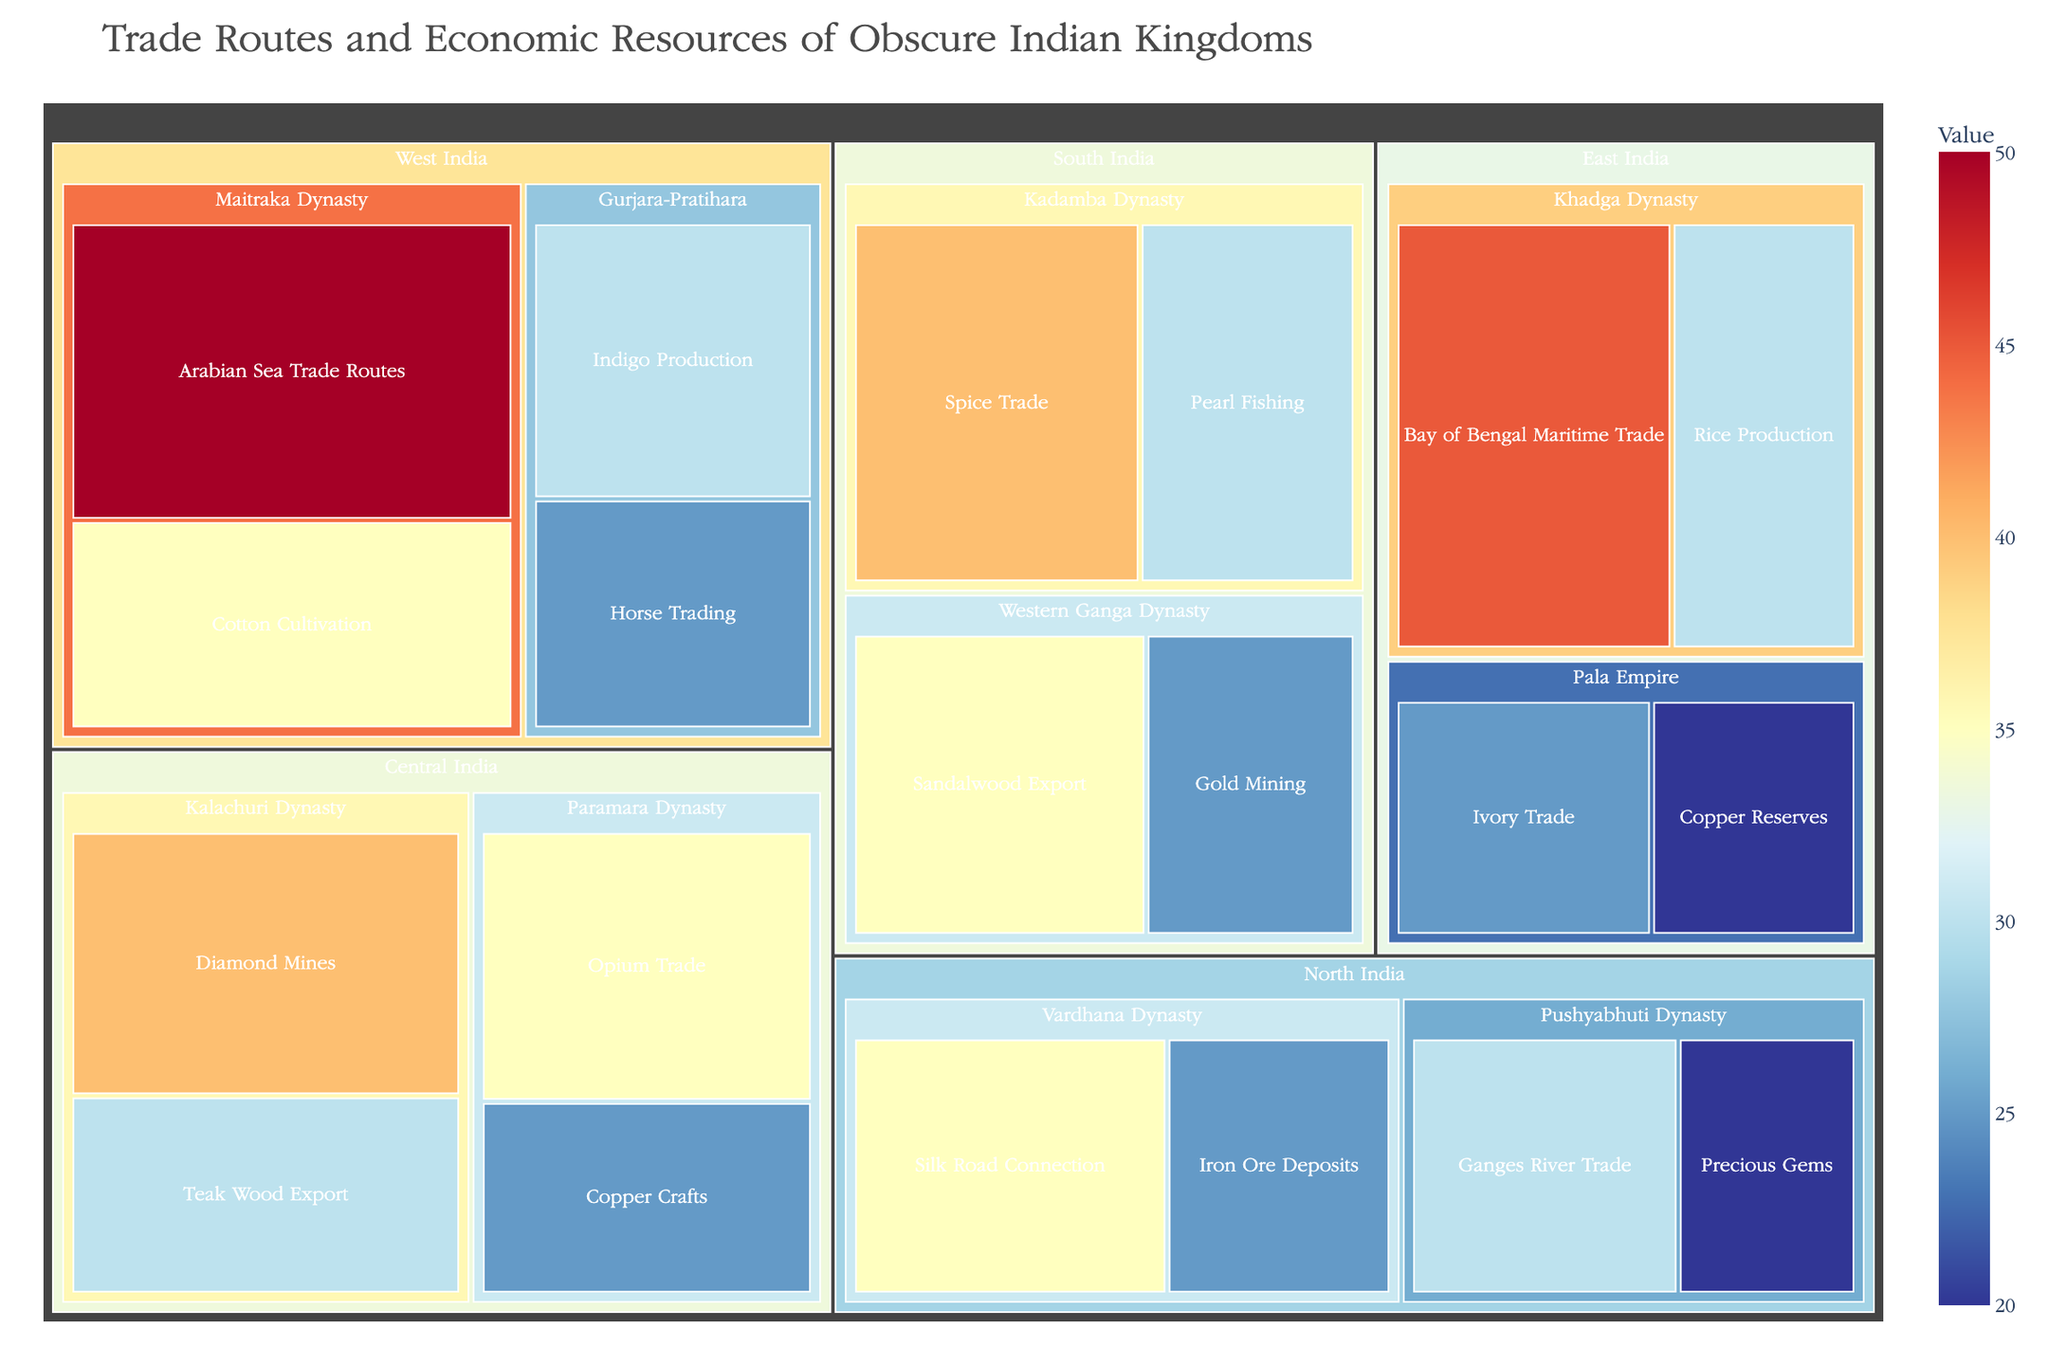What is the title of the Treemap? The title of the Treemap can be seen at the top of the figure.
Answer: Trade Routes and Economic Resources of Obscure Indian Kingdoms Which region controls the highest value trade route/resource? The region with the trade route/resource having the highest value can be identified by locating the largest block in the Treemap.
Answer: West India Which kingdom in South India controls the largest number of economic resources? In the South India region, the number of resources controlled by each kingdom can be counted.
Answer: Kadamba Dynasty What is the total value of trade routes/resources for the North India region? Add the values of all trade routes/resources for all kingdoms in the North India region. (35 + 25 + 30 + 20) = 110
Answer: 110 Which trade route/resource has the highest value in Central India? Locate the largest block within the Central India region.
Answer: Diamond Mines Which kingdom in East India has a higher total value of economic resources? Sum the values of trade routes/resources for each kingdom in East India. Khadga Dynasty: 45 + 30 = 75, Pala Empire: 20 + 25 = 45
Answer: Khadga Dynasty Compare the value of pearl fishing in South India with precious gems in North India. Which has a higher value? Identify the values of both the pearl fishing and precious gems, then compare them. Pearl Fishing: 30, Precious Gems: 20
Answer: Pearl Fishing How many kingdoms in the Treemap have a connection with a major water body for trade? Count kingdoms with trade routes/resources involving major water bodies (e.g., rivers, seas). Some examples include Arabian Sea Trade Routes and Bay of Bengal Maritime Trade.
Answer: 5 What is the combined value of the trade routes/resources controlled by the Maitraka Dynasty in West India? Add the values of the Arabian Sea Trade Routes and Cotton Cultivation for the Maitraka Dynasty (50 + 35) = 85.
Answer: 85 Which trade route/resource is depicted with the smallest block in the Treemap? The smallest block can be identified visually.
Answer: Copper Reserves in East India 